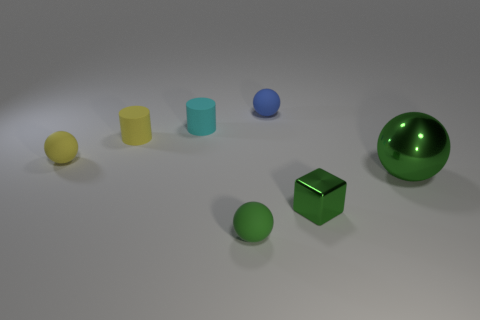Are there any blue rubber objects that have the same size as the yellow cylinder? There is a blue sphere in the image; however, it's not possible to ascertain from the image alone if it is made of rubber, and its size does not exactly match that of the yellow cylinder. The blue sphere appears to be smaller in scale. 